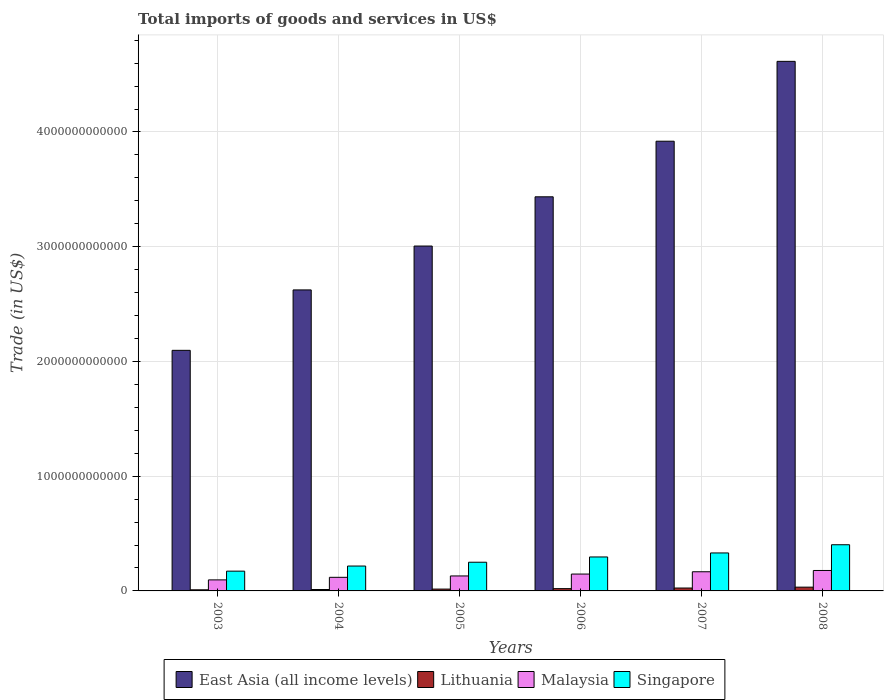How many groups of bars are there?
Make the answer very short. 6. Are the number of bars on each tick of the X-axis equal?
Provide a short and direct response. Yes. How many bars are there on the 5th tick from the left?
Offer a very short reply. 4. What is the total imports of goods and services in Lithuania in 2006?
Offer a very short reply. 1.99e+1. Across all years, what is the maximum total imports of goods and services in Lithuania?
Your response must be concise. 3.29e+1. Across all years, what is the minimum total imports of goods and services in Malaysia?
Ensure brevity in your answer.  9.62e+1. In which year was the total imports of goods and services in Malaysia minimum?
Ensure brevity in your answer.  2003. What is the total total imports of goods and services in Lithuania in the graph?
Ensure brevity in your answer.  1.16e+11. What is the difference between the total imports of goods and services in Singapore in 2003 and that in 2006?
Ensure brevity in your answer.  -1.24e+11. What is the difference between the total imports of goods and services in Singapore in 2007 and the total imports of goods and services in Malaysia in 2006?
Your answer should be very brief. 1.84e+11. What is the average total imports of goods and services in East Asia (all income levels) per year?
Your response must be concise. 3.28e+12. In the year 2005, what is the difference between the total imports of goods and services in Malaysia and total imports of goods and services in East Asia (all income levels)?
Offer a terse response. -2.88e+12. In how many years, is the total imports of goods and services in Lithuania greater than 2800000000000 US$?
Your response must be concise. 0. What is the ratio of the total imports of goods and services in Singapore in 2005 to that in 2008?
Keep it short and to the point. 0.62. Is the total imports of goods and services in East Asia (all income levels) in 2004 less than that in 2007?
Keep it short and to the point. Yes. What is the difference between the highest and the second highest total imports of goods and services in Singapore?
Provide a short and direct response. 7.15e+1. What is the difference between the highest and the lowest total imports of goods and services in Lithuania?
Keep it short and to the point. 2.31e+1. In how many years, is the total imports of goods and services in Lithuania greater than the average total imports of goods and services in Lithuania taken over all years?
Your answer should be very brief. 3. Is it the case that in every year, the sum of the total imports of goods and services in East Asia (all income levels) and total imports of goods and services in Singapore is greater than the sum of total imports of goods and services in Lithuania and total imports of goods and services in Malaysia?
Offer a terse response. No. What does the 1st bar from the left in 2004 represents?
Your answer should be very brief. East Asia (all income levels). What does the 1st bar from the right in 2006 represents?
Provide a succinct answer. Singapore. How many bars are there?
Ensure brevity in your answer.  24. How many years are there in the graph?
Make the answer very short. 6. What is the difference between two consecutive major ticks on the Y-axis?
Give a very brief answer. 1.00e+12. Does the graph contain grids?
Provide a succinct answer. Yes. How many legend labels are there?
Provide a succinct answer. 4. What is the title of the graph?
Your response must be concise. Total imports of goods and services in US$. Does "Estonia" appear as one of the legend labels in the graph?
Your answer should be very brief. No. What is the label or title of the Y-axis?
Offer a very short reply. Trade (in US$). What is the Trade (in US$) of East Asia (all income levels) in 2003?
Your answer should be very brief. 2.10e+12. What is the Trade (in US$) in Lithuania in 2003?
Your answer should be very brief. 9.77e+09. What is the Trade (in US$) of Malaysia in 2003?
Provide a short and direct response. 9.62e+1. What is the Trade (in US$) of Singapore in 2003?
Ensure brevity in your answer.  1.72e+11. What is the Trade (in US$) of East Asia (all income levels) in 2004?
Keep it short and to the point. 2.62e+12. What is the Trade (in US$) of Lithuania in 2004?
Your answer should be very brief. 1.23e+1. What is the Trade (in US$) in Malaysia in 2004?
Your answer should be very brief. 1.19e+11. What is the Trade (in US$) in Singapore in 2004?
Offer a very short reply. 2.17e+11. What is the Trade (in US$) in East Asia (all income levels) in 2005?
Make the answer very short. 3.01e+12. What is the Trade (in US$) of Lithuania in 2005?
Ensure brevity in your answer.  1.60e+1. What is the Trade (in US$) in Malaysia in 2005?
Your answer should be compact. 1.31e+11. What is the Trade (in US$) of Singapore in 2005?
Your response must be concise. 2.50e+11. What is the Trade (in US$) of East Asia (all income levels) in 2006?
Provide a short and direct response. 3.43e+12. What is the Trade (in US$) in Lithuania in 2006?
Offer a very short reply. 1.99e+1. What is the Trade (in US$) of Malaysia in 2006?
Your response must be concise. 1.47e+11. What is the Trade (in US$) in Singapore in 2006?
Keep it short and to the point. 2.96e+11. What is the Trade (in US$) in East Asia (all income levels) in 2007?
Provide a succinct answer. 3.92e+12. What is the Trade (in US$) in Lithuania in 2007?
Keep it short and to the point. 2.52e+1. What is the Trade (in US$) of Malaysia in 2007?
Offer a terse response. 1.67e+11. What is the Trade (in US$) in Singapore in 2007?
Offer a very short reply. 3.31e+11. What is the Trade (in US$) in East Asia (all income levels) in 2008?
Ensure brevity in your answer.  4.62e+12. What is the Trade (in US$) of Lithuania in 2008?
Provide a succinct answer. 3.29e+1. What is the Trade (in US$) of Malaysia in 2008?
Offer a terse response. 1.78e+11. What is the Trade (in US$) of Singapore in 2008?
Your answer should be very brief. 4.02e+11. Across all years, what is the maximum Trade (in US$) of East Asia (all income levels)?
Make the answer very short. 4.62e+12. Across all years, what is the maximum Trade (in US$) of Lithuania?
Offer a terse response. 3.29e+1. Across all years, what is the maximum Trade (in US$) in Malaysia?
Provide a succinct answer. 1.78e+11. Across all years, what is the maximum Trade (in US$) in Singapore?
Your response must be concise. 4.02e+11. Across all years, what is the minimum Trade (in US$) of East Asia (all income levels)?
Give a very brief answer. 2.10e+12. Across all years, what is the minimum Trade (in US$) of Lithuania?
Offer a terse response. 9.77e+09. Across all years, what is the minimum Trade (in US$) in Malaysia?
Your answer should be very brief. 9.62e+1. Across all years, what is the minimum Trade (in US$) in Singapore?
Offer a terse response. 1.72e+11. What is the total Trade (in US$) of East Asia (all income levels) in the graph?
Give a very brief answer. 1.97e+13. What is the total Trade (in US$) of Lithuania in the graph?
Ensure brevity in your answer.  1.16e+11. What is the total Trade (in US$) in Malaysia in the graph?
Offer a very short reply. 8.37e+11. What is the total Trade (in US$) of Singapore in the graph?
Offer a terse response. 1.67e+12. What is the difference between the Trade (in US$) of East Asia (all income levels) in 2003 and that in 2004?
Make the answer very short. -5.27e+11. What is the difference between the Trade (in US$) in Lithuania in 2003 and that in 2004?
Ensure brevity in your answer.  -2.56e+09. What is the difference between the Trade (in US$) in Malaysia in 2003 and that in 2004?
Provide a succinct answer. -2.24e+1. What is the difference between the Trade (in US$) in Singapore in 2003 and that in 2004?
Provide a succinct answer. -4.46e+1. What is the difference between the Trade (in US$) of East Asia (all income levels) in 2003 and that in 2005?
Your answer should be compact. -9.09e+11. What is the difference between the Trade (in US$) of Lithuania in 2003 and that in 2005?
Offer a terse response. -6.19e+09. What is the difference between the Trade (in US$) in Malaysia in 2003 and that in 2005?
Offer a terse response. -3.44e+1. What is the difference between the Trade (in US$) of Singapore in 2003 and that in 2005?
Offer a very short reply. -7.78e+1. What is the difference between the Trade (in US$) of East Asia (all income levels) in 2003 and that in 2006?
Your response must be concise. -1.34e+12. What is the difference between the Trade (in US$) of Lithuania in 2003 and that in 2006?
Offer a very short reply. -1.01e+1. What is the difference between the Trade (in US$) in Malaysia in 2003 and that in 2006?
Provide a succinct answer. -5.09e+1. What is the difference between the Trade (in US$) in Singapore in 2003 and that in 2006?
Offer a very short reply. -1.24e+11. What is the difference between the Trade (in US$) in East Asia (all income levels) in 2003 and that in 2007?
Ensure brevity in your answer.  -1.82e+12. What is the difference between the Trade (in US$) in Lithuania in 2003 and that in 2007?
Make the answer very short. -1.55e+1. What is the difference between the Trade (in US$) of Malaysia in 2003 and that in 2007?
Your answer should be compact. -7.09e+1. What is the difference between the Trade (in US$) in Singapore in 2003 and that in 2007?
Offer a terse response. -1.59e+11. What is the difference between the Trade (in US$) of East Asia (all income levels) in 2003 and that in 2008?
Keep it short and to the point. -2.52e+12. What is the difference between the Trade (in US$) of Lithuania in 2003 and that in 2008?
Provide a short and direct response. -2.31e+1. What is the difference between the Trade (in US$) of Malaysia in 2003 and that in 2008?
Provide a succinct answer. -8.20e+1. What is the difference between the Trade (in US$) in Singapore in 2003 and that in 2008?
Give a very brief answer. -2.30e+11. What is the difference between the Trade (in US$) of East Asia (all income levels) in 2004 and that in 2005?
Provide a short and direct response. -3.82e+11. What is the difference between the Trade (in US$) of Lithuania in 2004 and that in 2005?
Ensure brevity in your answer.  -3.64e+09. What is the difference between the Trade (in US$) in Malaysia in 2004 and that in 2005?
Make the answer very short. -1.20e+1. What is the difference between the Trade (in US$) of Singapore in 2004 and that in 2005?
Provide a succinct answer. -3.32e+1. What is the difference between the Trade (in US$) in East Asia (all income levels) in 2004 and that in 2006?
Provide a short and direct response. -8.12e+11. What is the difference between the Trade (in US$) in Lithuania in 2004 and that in 2006?
Keep it short and to the point. -7.59e+09. What is the difference between the Trade (in US$) in Malaysia in 2004 and that in 2006?
Your answer should be very brief. -2.85e+1. What is the difference between the Trade (in US$) in Singapore in 2004 and that in 2006?
Offer a terse response. -7.91e+1. What is the difference between the Trade (in US$) in East Asia (all income levels) in 2004 and that in 2007?
Make the answer very short. -1.30e+12. What is the difference between the Trade (in US$) of Lithuania in 2004 and that in 2007?
Ensure brevity in your answer.  -1.29e+1. What is the difference between the Trade (in US$) of Malaysia in 2004 and that in 2007?
Give a very brief answer. -4.85e+1. What is the difference between the Trade (in US$) in Singapore in 2004 and that in 2007?
Provide a succinct answer. -1.14e+11. What is the difference between the Trade (in US$) of East Asia (all income levels) in 2004 and that in 2008?
Ensure brevity in your answer.  -1.99e+12. What is the difference between the Trade (in US$) of Lithuania in 2004 and that in 2008?
Offer a terse response. -2.06e+1. What is the difference between the Trade (in US$) of Malaysia in 2004 and that in 2008?
Make the answer very short. -5.96e+1. What is the difference between the Trade (in US$) in Singapore in 2004 and that in 2008?
Your answer should be very brief. -1.86e+11. What is the difference between the Trade (in US$) of East Asia (all income levels) in 2005 and that in 2006?
Your answer should be very brief. -4.29e+11. What is the difference between the Trade (in US$) in Lithuania in 2005 and that in 2006?
Give a very brief answer. -3.95e+09. What is the difference between the Trade (in US$) of Malaysia in 2005 and that in 2006?
Give a very brief answer. -1.65e+1. What is the difference between the Trade (in US$) of Singapore in 2005 and that in 2006?
Your response must be concise. -4.59e+1. What is the difference between the Trade (in US$) in East Asia (all income levels) in 2005 and that in 2007?
Your answer should be compact. -9.14e+11. What is the difference between the Trade (in US$) of Lithuania in 2005 and that in 2007?
Offer a terse response. -9.27e+09. What is the difference between the Trade (in US$) of Malaysia in 2005 and that in 2007?
Give a very brief answer. -3.65e+1. What is the difference between the Trade (in US$) in Singapore in 2005 and that in 2007?
Give a very brief answer. -8.10e+1. What is the difference between the Trade (in US$) in East Asia (all income levels) in 2005 and that in 2008?
Offer a very short reply. -1.61e+12. What is the difference between the Trade (in US$) in Lithuania in 2005 and that in 2008?
Make the answer very short. -1.69e+1. What is the difference between the Trade (in US$) of Malaysia in 2005 and that in 2008?
Your answer should be very brief. -4.76e+1. What is the difference between the Trade (in US$) of Singapore in 2005 and that in 2008?
Your answer should be very brief. -1.52e+11. What is the difference between the Trade (in US$) in East Asia (all income levels) in 2006 and that in 2007?
Provide a succinct answer. -4.84e+11. What is the difference between the Trade (in US$) in Lithuania in 2006 and that in 2007?
Offer a terse response. -5.32e+09. What is the difference between the Trade (in US$) in Malaysia in 2006 and that in 2007?
Provide a succinct answer. -2.00e+1. What is the difference between the Trade (in US$) of Singapore in 2006 and that in 2007?
Provide a short and direct response. -3.50e+1. What is the difference between the Trade (in US$) in East Asia (all income levels) in 2006 and that in 2008?
Provide a succinct answer. -1.18e+12. What is the difference between the Trade (in US$) in Lithuania in 2006 and that in 2008?
Give a very brief answer. -1.30e+1. What is the difference between the Trade (in US$) of Malaysia in 2006 and that in 2008?
Your answer should be compact. -3.11e+1. What is the difference between the Trade (in US$) of Singapore in 2006 and that in 2008?
Provide a succinct answer. -1.07e+11. What is the difference between the Trade (in US$) of East Asia (all income levels) in 2007 and that in 2008?
Ensure brevity in your answer.  -6.96e+11. What is the difference between the Trade (in US$) of Lithuania in 2007 and that in 2008?
Give a very brief answer. -7.65e+09. What is the difference between the Trade (in US$) of Malaysia in 2007 and that in 2008?
Provide a succinct answer. -1.11e+1. What is the difference between the Trade (in US$) in Singapore in 2007 and that in 2008?
Give a very brief answer. -7.15e+1. What is the difference between the Trade (in US$) in East Asia (all income levels) in 2003 and the Trade (in US$) in Lithuania in 2004?
Provide a succinct answer. 2.08e+12. What is the difference between the Trade (in US$) in East Asia (all income levels) in 2003 and the Trade (in US$) in Malaysia in 2004?
Your response must be concise. 1.98e+12. What is the difference between the Trade (in US$) in East Asia (all income levels) in 2003 and the Trade (in US$) in Singapore in 2004?
Offer a terse response. 1.88e+12. What is the difference between the Trade (in US$) of Lithuania in 2003 and the Trade (in US$) of Malaysia in 2004?
Provide a short and direct response. -1.09e+11. What is the difference between the Trade (in US$) in Lithuania in 2003 and the Trade (in US$) in Singapore in 2004?
Keep it short and to the point. -2.07e+11. What is the difference between the Trade (in US$) in Malaysia in 2003 and the Trade (in US$) in Singapore in 2004?
Offer a very short reply. -1.21e+11. What is the difference between the Trade (in US$) in East Asia (all income levels) in 2003 and the Trade (in US$) in Lithuania in 2005?
Your answer should be very brief. 2.08e+12. What is the difference between the Trade (in US$) of East Asia (all income levels) in 2003 and the Trade (in US$) of Malaysia in 2005?
Your response must be concise. 1.97e+12. What is the difference between the Trade (in US$) in East Asia (all income levels) in 2003 and the Trade (in US$) in Singapore in 2005?
Offer a very short reply. 1.85e+12. What is the difference between the Trade (in US$) in Lithuania in 2003 and the Trade (in US$) in Malaysia in 2005?
Keep it short and to the point. -1.21e+11. What is the difference between the Trade (in US$) of Lithuania in 2003 and the Trade (in US$) of Singapore in 2005?
Provide a short and direct response. -2.40e+11. What is the difference between the Trade (in US$) in Malaysia in 2003 and the Trade (in US$) in Singapore in 2005?
Provide a short and direct response. -1.54e+11. What is the difference between the Trade (in US$) of East Asia (all income levels) in 2003 and the Trade (in US$) of Lithuania in 2006?
Your answer should be compact. 2.08e+12. What is the difference between the Trade (in US$) in East Asia (all income levels) in 2003 and the Trade (in US$) in Malaysia in 2006?
Give a very brief answer. 1.95e+12. What is the difference between the Trade (in US$) in East Asia (all income levels) in 2003 and the Trade (in US$) in Singapore in 2006?
Offer a terse response. 1.80e+12. What is the difference between the Trade (in US$) of Lithuania in 2003 and the Trade (in US$) of Malaysia in 2006?
Offer a terse response. -1.37e+11. What is the difference between the Trade (in US$) in Lithuania in 2003 and the Trade (in US$) in Singapore in 2006?
Your answer should be very brief. -2.86e+11. What is the difference between the Trade (in US$) in Malaysia in 2003 and the Trade (in US$) in Singapore in 2006?
Offer a terse response. -2.00e+11. What is the difference between the Trade (in US$) of East Asia (all income levels) in 2003 and the Trade (in US$) of Lithuania in 2007?
Provide a succinct answer. 2.07e+12. What is the difference between the Trade (in US$) in East Asia (all income levels) in 2003 and the Trade (in US$) in Malaysia in 2007?
Give a very brief answer. 1.93e+12. What is the difference between the Trade (in US$) of East Asia (all income levels) in 2003 and the Trade (in US$) of Singapore in 2007?
Your answer should be compact. 1.77e+12. What is the difference between the Trade (in US$) in Lithuania in 2003 and the Trade (in US$) in Malaysia in 2007?
Your response must be concise. -1.57e+11. What is the difference between the Trade (in US$) of Lithuania in 2003 and the Trade (in US$) of Singapore in 2007?
Make the answer very short. -3.21e+11. What is the difference between the Trade (in US$) in Malaysia in 2003 and the Trade (in US$) in Singapore in 2007?
Keep it short and to the point. -2.35e+11. What is the difference between the Trade (in US$) in East Asia (all income levels) in 2003 and the Trade (in US$) in Lithuania in 2008?
Give a very brief answer. 2.06e+12. What is the difference between the Trade (in US$) of East Asia (all income levels) in 2003 and the Trade (in US$) of Malaysia in 2008?
Provide a short and direct response. 1.92e+12. What is the difference between the Trade (in US$) in East Asia (all income levels) in 2003 and the Trade (in US$) in Singapore in 2008?
Your answer should be very brief. 1.69e+12. What is the difference between the Trade (in US$) in Lithuania in 2003 and the Trade (in US$) in Malaysia in 2008?
Give a very brief answer. -1.68e+11. What is the difference between the Trade (in US$) in Lithuania in 2003 and the Trade (in US$) in Singapore in 2008?
Make the answer very short. -3.93e+11. What is the difference between the Trade (in US$) in Malaysia in 2003 and the Trade (in US$) in Singapore in 2008?
Give a very brief answer. -3.06e+11. What is the difference between the Trade (in US$) of East Asia (all income levels) in 2004 and the Trade (in US$) of Lithuania in 2005?
Provide a short and direct response. 2.61e+12. What is the difference between the Trade (in US$) in East Asia (all income levels) in 2004 and the Trade (in US$) in Malaysia in 2005?
Give a very brief answer. 2.49e+12. What is the difference between the Trade (in US$) of East Asia (all income levels) in 2004 and the Trade (in US$) of Singapore in 2005?
Offer a very short reply. 2.37e+12. What is the difference between the Trade (in US$) of Lithuania in 2004 and the Trade (in US$) of Malaysia in 2005?
Offer a very short reply. -1.18e+11. What is the difference between the Trade (in US$) in Lithuania in 2004 and the Trade (in US$) in Singapore in 2005?
Offer a very short reply. -2.38e+11. What is the difference between the Trade (in US$) in Malaysia in 2004 and the Trade (in US$) in Singapore in 2005?
Keep it short and to the point. -1.32e+11. What is the difference between the Trade (in US$) in East Asia (all income levels) in 2004 and the Trade (in US$) in Lithuania in 2006?
Provide a succinct answer. 2.60e+12. What is the difference between the Trade (in US$) of East Asia (all income levels) in 2004 and the Trade (in US$) of Malaysia in 2006?
Give a very brief answer. 2.48e+12. What is the difference between the Trade (in US$) of East Asia (all income levels) in 2004 and the Trade (in US$) of Singapore in 2006?
Your answer should be very brief. 2.33e+12. What is the difference between the Trade (in US$) in Lithuania in 2004 and the Trade (in US$) in Malaysia in 2006?
Your answer should be very brief. -1.35e+11. What is the difference between the Trade (in US$) in Lithuania in 2004 and the Trade (in US$) in Singapore in 2006?
Provide a succinct answer. -2.84e+11. What is the difference between the Trade (in US$) of Malaysia in 2004 and the Trade (in US$) of Singapore in 2006?
Offer a terse response. -1.77e+11. What is the difference between the Trade (in US$) of East Asia (all income levels) in 2004 and the Trade (in US$) of Lithuania in 2007?
Your answer should be compact. 2.60e+12. What is the difference between the Trade (in US$) of East Asia (all income levels) in 2004 and the Trade (in US$) of Malaysia in 2007?
Provide a short and direct response. 2.46e+12. What is the difference between the Trade (in US$) in East Asia (all income levels) in 2004 and the Trade (in US$) in Singapore in 2007?
Your answer should be very brief. 2.29e+12. What is the difference between the Trade (in US$) in Lithuania in 2004 and the Trade (in US$) in Malaysia in 2007?
Offer a terse response. -1.55e+11. What is the difference between the Trade (in US$) of Lithuania in 2004 and the Trade (in US$) of Singapore in 2007?
Offer a terse response. -3.19e+11. What is the difference between the Trade (in US$) of Malaysia in 2004 and the Trade (in US$) of Singapore in 2007?
Your answer should be very brief. -2.13e+11. What is the difference between the Trade (in US$) in East Asia (all income levels) in 2004 and the Trade (in US$) in Lithuania in 2008?
Offer a terse response. 2.59e+12. What is the difference between the Trade (in US$) of East Asia (all income levels) in 2004 and the Trade (in US$) of Malaysia in 2008?
Keep it short and to the point. 2.45e+12. What is the difference between the Trade (in US$) of East Asia (all income levels) in 2004 and the Trade (in US$) of Singapore in 2008?
Provide a short and direct response. 2.22e+12. What is the difference between the Trade (in US$) of Lithuania in 2004 and the Trade (in US$) of Malaysia in 2008?
Offer a terse response. -1.66e+11. What is the difference between the Trade (in US$) in Lithuania in 2004 and the Trade (in US$) in Singapore in 2008?
Your answer should be compact. -3.90e+11. What is the difference between the Trade (in US$) of Malaysia in 2004 and the Trade (in US$) of Singapore in 2008?
Your answer should be compact. -2.84e+11. What is the difference between the Trade (in US$) of East Asia (all income levels) in 2005 and the Trade (in US$) of Lithuania in 2006?
Keep it short and to the point. 2.99e+12. What is the difference between the Trade (in US$) of East Asia (all income levels) in 2005 and the Trade (in US$) of Malaysia in 2006?
Make the answer very short. 2.86e+12. What is the difference between the Trade (in US$) of East Asia (all income levels) in 2005 and the Trade (in US$) of Singapore in 2006?
Offer a terse response. 2.71e+12. What is the difference between the Trade (in US$) of Lithuania in 2005 and the Trade (in US$) of Malaysia in 2006?
Provide a succinct answer. -1.31e+11. What is the difference between the Trade (in US$) of Lithuania in 2005 and the Trade (in US$) of Singapore in 2006?
Provide a succinct answer. -2.80e+11. What is the difference between the Trade (in US$) in Malaysia in 2005 and the Trade (in US$) in Singapore in 2006?
Your answer should be compact. -1.65e+11. What is the difference between the Trade (in US$) of East Asia (all income levels) in 2005 and the Trade (in US$) of Lithuania in 2007?
Provide a succinct answer. 2.98e+12. What is the difference between the Trade (in US$) in East Asia (all income levels) in 2005 and the Trade (in US$) in Malaysia in 2007?
Offer a very short reply. 2.84e+12. What is the difference between the Trade (in US$) of East Asia (all income levels) in 2005 and the Trade (in US$) of Singapore in 2007?
Provide a short and direct response. 2.67e+12. What is the difference between the Trade (in US$) of Lithuania in 2005 and the Trade (in US$) of Malaysia in 2007?
Your answer should be very brief. -1.51e+11. What is the difference between the Trade (in US$) in Lithuania in 2005 and the Trade (in US$) in Singapore in 2007?
Provide a short and direct response. -3.15e+11. What is the difference between the Trade (in US$) of Malaysia in 2005 and the Trade (in US$) of Singapore in 2007?
Offer a very short reply. -2.00e+11. What is the difference between the Trade (in US$) of East Asia (all income levels) in 2005 and the Trade (in US$) of Lithuania in 2008?
Your answer should be compact. 2.97e+12. What is the difference between the Trade (in US$) in East Asia (all income levels) in 2005 and the Trade (in US$) in Malaysia in 2008?
Provide a succinct answer. 2.83e+12. What is the difference between the Trade (in US$) of East Asia (all income levels) in 2005 and the Trade (in US$) of Singapore in 2008?
Provide a succinct answer. 2.60e+12. What is the difference between the Trade (in US$) of Lithuania in 2005 and the Trade (in US$) of Malaysia in 2008?
Keep it short and to the point. -1.62e+11. What is the difference between the Trade (in US$) in Lithuania in 2005 and the Trade (in US$) in Singapore in 2008?
Your answer should be compact. -3.87e+11. What is the difference between the Trade (in US$) of Malaysia in 2005 and the Trade (in US$) of Singapore in 2008?
Offer a very short reply. -2.72e+11. What is the difference between the Trade (in US$) of East Asia (all income levels) in 2006 and the Trade (in US$) of Lithuania in 2007?
Your answer should be compact. 3.41e+12. What is the difference between the Trade (in US$) in East Asia (all income levels) in 2006 and the Trade (in US$) in Malaysia in 2007?
Ensure brevity in your answer.  3.27e+12. What is the difference between the Trade (in US$) of East Asia (all income levels) in 2006 and the Trade (in US$) of Singapore in 2007?
Keep it short and to the point. 3.10e+12. What is the difference between the Trade (in US$) in Lithuania in 2006 and the Trade (in US$) in Malaysia in 2007?
Offer a terse response. -1.47e+11. What is the difference between the Trade (in US$) in Lithuania in 2006 and the Trade (in US$) in Singapore in 2007?
Your answer should be very brief. -3.11e+11. What is the difference between the Trade (in US$) of Malaysia in 2006 and the Trade (in US$) of Singapore in 2007?
Your answer should be compact. -1.84e+11. What is the difference between the Trade (in US$) of East Asia (all income levels) in 2006 and the Trade (in US$) of Lithuania in 2008?
Make the answer very short. 3.40e+12. What is the difference between the Trade (in US$) in East Asia (all income levels) in 2006 and the Trade (in US$) in Malaysia in 2008?
Ensure brevity in your answer.  3.26e+12. What is the difference between the Trade (in US$) of East Asia (all income levels) in 2006 and the Trade (in US$) of Singapore in 2008?
Your answer should be very brief. 3.03e+12. What is the difference between the Trade (in US$) in Lithuania in 2006 and the Trade (in US$) in Malaysia in 2008?
Your answer should be very brief. -1.58e+11. What is the difference between the Trade (in US$) in Lithuania in 2006 and the Trade (in US$) in Singapore in 2008?
Provide a succinct answer. -3.83e+11. What is the difference between the Trade (in US$) of Malaysia in 2006 and the Trade (in US$) of Singapore in 2008?
Make the answer very short. -2.55e+11. What is the difference between the Trade (in US$) in East Asia (all income levels) in 2007 and the Trade (in US$) in Lithuania in 2008?
Provide a succinct answer. 3.89e+12. What is the difference between the Trade (in US$) in East Asia (all income levels) in 2007 and the Trade (in US$) in Malaysia in 2008?
Make the answer very short. 3.74e+12. What is the difference between the Trade (in US$) in East Asia (all income levels) in 2007 and the Trade (in US$) in Singapore in 2008?
Keep it short and to the point. 3.52e+12. What is the difference between the Trade (in US$) in Lithuania in 2007 and the Trade (in US$) in Malaysia in 2008?
Make the answer very short. -1.53e+11. What is the difference between the Trade (in US$) in Lithuania in 2007 and the Trade (in US$) in Singapore in 2008?
Keep it short and to the point. -3.77e+11. What is the difference between the Trade (in US$) in Malaysia in 2007 and the Trade (in US$) in Singapore in 2008?
Make the answer very short. -2.35e+11. What is the average Trade (in US$) in East Asia (all income levels) per year?
Your response must be concise. 3.28e+12. What is the average Trade (in US$) of Lithuania per year?
Your answer should be compact. 1.93e+1. What is the average Trade (in US$) of Malaysia per year?
Provide a short and direct response. 1.40e+11. What is the average Trade (in US$) in Singapore per year?
Your answer should be very brief. 2.78e+11. In the year 2003, what is the difference between the Trade (in US$) in East Asia (all income levels) and Trade (in US$) in Lithuania?
Offer a terse response. 2.09e+12. In the year 2003, what is the difference between the Trade (in US$) of East Asia (all income levels) and Trade (in US$) of Malaysia?
Your response must be concise. 2.00e+12. In the year 2003, what is the difference between the Trade (in US$) in East Asia (all income levels) and Trade (in US$) in Singapore?
Ensure brevity in your answer.  1.92e+12. In the year 2003, what is the difference between the Trade (in US$) in Lithuania and Trade (in US$) in Malaysia?
Your answer should be very brief. -8.64e+1. In the year 2003, what is the difference between the Trade (in US$) in Lithuania and Trade (in US$) in Singapore?
Make the answer very short. -1.63e+11. In the year 2003, what is the difference between the Trade (in US$) of Malaysia and Trade (in US$) of Singapore?
Offer a terse response. -7.61e+1. In the year 2004, what is the difference between the Trade (in US$) of East Asia (all income levels) and Trade (in US$) of Lithuania?
Your answer should be compact. 2.61e+12. In the year 2004, what is the difference between the Trade (in US$) in East Asia (all income levels) and Trade (in US$) in Malaysia?
Provide a succinct answer. 2.50e+12. In the year 2004, what is the difference between the Trade (in US$) of East Asia (all income levels) and Trade (in US$) of Singapore?
Give a very brief answer. 2.41e+12. In the year 2004, what is the difference between the Trade (in US$) in Lithuania and Trade (in US$) in Malaysia?
Ensure brevity in your answer.  -1.06e+11. In the year 2004, what is the difference between the Trade (in US$) of Lithuania and Trade (in US$) of Singapore?
Offer a very short reply. -2.05e+11. In the year 2004, what is the difference between the Trade (in US$) in Malaysia and Trade (in US$) in Singapore?
Keep it short and to the point. -9.84e+1. In the year 2005, what is the difference between the Trade (in US$) in East Asia (all income levels) and Trade (in US$) in Lithuania?
Your response must be concise. 2.99e+12. In the year 2005, what is the difference between the Trade (in US$) in East Asia (all income levels) and Trade (in US$) in Malaysia?
Ensure brevity in your answer.  2.88e+12. In the year 2005, what is the difference between the Trade (in US$) in East Asia (all income levels) and Trade (in US$) in Singapore?
Your answer should be very brief. 2.76e+12. In the year 2005, what is the difference between the Trade (in US$) in Lithuania and Trade (in US$) in Malaysia?
Provide a short and direct response. -1.15e+11. In the year 2005, what is the difference between the Trade (in US$) in Lithuania and Trade (in US$) in Singapore?
Offer a very short reply. -2.34e+11. In the year 2005, what is the difference between the Trade (in US$) in Malaysia and Trade (in US$) in Singapore?
Keep it short and to the point. -1.20e+11. In the year 2006, what is the difference between the Trade (in US$) in East Asia (all income levels) and Trade (in US$) in Lithuania?
Provide a short and direct response. 3.42e+12. In the year 2006, what is the difference between the Trade (in US$) in East Asia (all income levels) and Trade (in US$) in Malaysia?
Ensure brevity in your answer.  3.29e+12. In the year 2006, what is the difference between the Trade (in US$) of East Asia (all income levels) and Trade (in US$) of Singapore?
Offer a terse response. 3.14e+12. In the year 2006, what is the difference between the Trade (in US$) of Lithuania and Trade (in US$) of Malaysia?
Provide a succinct answer. -1.27e+11. In the year 2006, what is the difference between the Trade (in US$) in Lithuania and Trade (in US$) in Singapore?
Provide a succinct answer. -2.76e+11. In the year 2006, what is the difference between the Trade (in US$) in Malaysia and Trade (in US$) in Singapore?
Make the answer very short. -1.49e+11. In the year 2007, what is the difference between the Trade (in US$) in East Asia (all income levels) and Trade (in US$) in Lithuania?
Make the answer very short. 3.89e+12. In the year 2007, what is the difference between the Trade (in US$) of East Asia (all income levels) and Trade (in US$) of Malaysia?
Provide a short and direct response. 3.75e+12. In the year 2007, what is the difference between the Trade (in US$) of East Asia (all income levels) and Trade (in US$) of Singapore?
Your response must be concise. 3.59e+12. In the year 2007, what is the difference between the Trade (in US$) in Lithuania and Trade (in US$) in Malaysia?
Provide a short and direct response. -1.42e+11. In the year 2007, what is the difference between the Trade (in US$) in Lithuania and Trade (in US$) in Singapore?
Give a very brief answer. -3.06e+11. In the year 2007, what is the difference between the Trade (in US$) in Malaysia and Trade (in US$) in Singapore?
Provide a succinct answer. -1.64e+11. In the year 2008, what is the difference between the Trade (in US$) of East Asia (all income levels) and Trade (in US$) of Lithuania?
Make the answer very short. 4.58e+12. In the year 2008, what is the difference between the Trade (in US$) of East Asia (all income levels) and Trade (in US$) of Malaysia?
Your response must be concise. 4.44e+12. In the year 2008, what is the difference between the Trade (in US$) of East Asia (all income levels) and Trade (in US$) of Singapore?
Your response must be concise. 4.21e+12. In the year 2008, what is the difference between the Trade (in US$) of Lithuania and Trade (in US$) of Malaysia?
Make the answer very short. -1.45e+11. In the year 2008, what is the difference between the Trade (in US$) of Lithuania and Trade (in US$) of Singapore?
Make the answer very short. -3.70e+11. In the year 2008, what is the difference between the Trade (in US$) in Malaysia and Trade (in US$) in Singapore?
Give a very brief answer. -2.24e+11. What is the ratio of the Trade (in US$) in East Asia (all income levels) in 2003 to that in 2004?
Offer a terse response. 0.8. What is the ratio of the Trade (in US$) in Lithuania in 2003 to that in 2004?
Ensure brevity in your answer.  0.79. What is the ratio of the Trade (in US$) of Malaysia in 2003 to that in 2004?
Ensure brevity in your answer.  0.81. What is the ratio of the Trade (in US$) of Singapore in 2003 to that in 2004?
Provide a short and direct response. 0.79. What is the ratio of the Trade (in US$) of East Asia (all income levels) in 2003 to that in 2005?
Your response must be concise. 0.7. What is the ratio of the Trade (in US$) in Lithuania in 2003 to that in 2005?
Offer a terse response. 0.61. What is the ratio of the Trade (in US$) in Malaysia in 2003 to that in 2005?
Provide a succinct answer. 0.74. What is the ratio of the Trade (in US$) of Singapore in 2003 to that in 2005?
Make the answer very short. 0.69. What is the ratio of the Trade (in US$) of East Asia (all income levels) in 2003 to that in 2006?
Offer a very short reply. 0.61. What is the ratio of the Trade (in US$) of Lithuania in 2003 to that in 2006?
Your answer should be compact. 0.49. What is the ratio of the Trade (in US$) in Malaysia in 2003 to that in 2006?
Provide a short and direct response. 0.65. What is the ratio of the Trade (in US$) in Singapore in 2003 to that in 2006?
Your answer should be compact. 0.58. What is the ratio of the Trade (in US$) of East Asia (all income levels) in 2003 to that in 2007?
Provide a succinct answer. 0.54. What is the ratio of the Trade (in US$) in Lithuania in 2003 to that in 2007?
Your answer should be compact. 0.39. What is the ratio of the Trade (in US$) of Malaysia in 2003 to that in 2007?
Keep it short and to the point. 0.58. What is the ratio of the Trade (in US$) in Singapore in 2003 to that in 2007?
Ensure brevity in your answer.  0.52. What is the ratio of the Trade (in US$) of East Asia (all income levels) in 2003 to that in 2008?
Your answer should be very brief. 0.45. What is the ratio of the Trade (in US$) in Lithuania in 2003 to that in 2008?
Offer a very short reply. 0.3. What is the ratio of the Trade (in US$) in Malaysia in 2003 to that in 2008?
Keep it short and to the point. 0.54. What is the ratio of the Trade (in US$) of Singapore in 2003 to that in 2008?
Ensure brevity in your answer.  0.43. What is the ratio of the Trade (in US$) of East Asia (all income levels) in 2004 to that in 2005?
Your answer should be very brief. 0.87. What is the ratio of the Trade (in US$) in Lithuania in 2004 to that in 2005?
Keep it short and to the point. 0.77. What is the ratio of the Trade (in US$) in Malaysia in 2004 to that in 2005?
Keep it short and to the point. 0.91. What is the ratio of the Trade (in US$) of Singapore in 2004 to that in 2005?
Your answer should be compact. 0.87. What is the ratio of the Trade (in US$) in East Asia (all income levels) in 2004 to that in 2006?
Offer a terse response. 0.76. What is the ratio of the Trade (in US$) in Lithuania in 2004 to that in 2006?
Make the answer very short. 0.62. What is the ratio of the Trade (in US$) of Malaysia in 2004 to that in 2006?
Your response must be concise. 0.81. What is the ratio of the Trade (in US$) of Singapore in 2004 to that in 2006?
Provide a short and direct response. 0.73. What is the ratio of the Trade (in US$) in East Asia (all income levels) in 2004 to that in 2007?
Make the answer very short. 0.67. What is the ratio of the Trade (in US$) in Lithuania in 2004 to that in 2007?
Provide a short and direct response. 0.49. What is the ratio of the Trade (in US$) of Malaysia in 2004 to that in 2007?
Provide a short and direct response. 0.71. What is the ratio of the Trade (in US$) of Singapore in 2004 to that in 2007?
Your answer should be compact. 0.66. What is the ratio of the Trade (in US$) in East Asia (all income levels) in 2004 to that in 2008?
Keep it short and to the point. 0.57. What is the ratio of the Trade (in US$) of Lithuania in 2004 to that in 2008?
Provide a short and direct response. 0.37. What is the ratio of the Trade (in US$) in Malaysia in 2004 to that in 2008?
Keep it short and to the point. 0.67. What is the ratio of the Trade (in US$) of Singapore in 2004 to that in 2008?
Offer a terse response. 0.54. What is the ratio of the Trade (in US$) in East Asia (all income levels) in 2005 to that in 2006?
Keep it short and to the point. 0.88. What is the ratio of the Trade (in US$) of Lithuania in 2005 to that in 2006?
Give a very brief answer. 0.8. What is the ratio of the Trade (in US$) in Malaysia in 2005 to that in 2006?
Give a very brief answer. 0.89. What is the ratio of the Trade (in US$) of Singapore in 2005 to that in 2006?
Provide a succinct answer. 0.84. What is the ratio of the Trade (in US$) in East Asia (all income levels) in 2005 to that in 2007?
Offer a terse response. 0.77. What is the ratio of the Trade (in US$) in Lithuania in 2005 to that in 2007?
Offer a very short reply. 0.63. What is the ratio of the Trade (in US$) of Malaysia in 2005 to that in 2007?
Provide a short and direct response. 0.78. What is the ratio of the Trade (in US$) in Singapore in 2005 to that in 2007?
Offer a very short reply. 0.76. What is the ratio of the Trade (in US$) in East Asia (all income levels) in 2005 to that in 2008?
Ensure brevity in your answer.  0.65. What is the ratio of the Trade (in US$) of Lithuania in 2005 to that in 2008?
Offer a very short reply. 0.49. What is the ratio of the Trade (in US$) in Malaysia in 2005 to that in 2008?
Offer a very short reply. 0.73. What is the ratio of the Trade (in US$) in Singapore in 2005 to that in 2008?
Keep it short and to the point. 0.62. What is the ratio of the Trade (in US$) in East Asia (all income levels) in 2006 to that in 2007?
Provide a succinct answer. 0.88. What is the ratio of the Trade (in US$) of Lithuania in 2006 to that in 2007?
Your response must be concise. 0.79. What is the ratio of the Trade (in US$) in Malaysia in 2006 to that in 2007?
Your answer should be very brief. 0.88. What is the ratio of the Trade (in US$) in Singapore in 2006 to that in 2007?
Offer a terse response. 0.89. What is the ratio of the Trade (in US$) in East Asia (all income levels) in 2006 to that in 2008?
Your answer should be compact. 0.74. What is the ratio of the Trade (in US$) in Lithuania in 2006 to that in 2008?
Your response must be concise. 0.61. What is the ratio of the Trade (in US$) in Malaysia in 2006 to that in 2008?
Offer a terse response. 0.83. What is the ratio of the Trade (in US$) of Singapore in 2006 to that in 2008?
Your answer should be very brief. 0.74. What is the ratio of the Trade (in US$) of East Asia (all income levels) in 2007 to that in 2008?
Your answer should be very brief. 0.85. What is the ratio of the Trade (in US$) in Lithuania in 2007 to that in 2008?
Offer a very short reply. 0.77. What is the ratio of the Trade (in US$) of Malaysia in 2007 to that in 2008?
Make the answer very short. 0.94. What is the ratio of the Trade (in US$) in Singapore in 2007 to that in 2008?
Your response must be concise. 0.82. What is the difference between the highest and the second highest Trade (in US$) of East Asia (all income levels)?
Give a very brief answer. 6.96e+11. What is the difference between the highest and the second highest Trade (in US$) in Lithuania?
Give a very brief answer. 7.65e+09. What is the difference between the highest and the second highest Trade (in US$) of Malaysia?
Offer a very short reply. 1.11e+1. What is the difference between the highest and the second highest Trade (in US$) of Singapore?
Your answer should be compact. 7.15e+1. What is the difference between the highest and the lowest Trade (in US$) in East Asia (all income levels)?
Offer a terse response. 2.52e+12. What is the difference between the highest and the lowest Trade (in US$) in Lithuania?
Ensure brevity in your answer.  2.31e+1. What is the difference between the highest and the lowest Trade (in US$) of Malaysia?
Ensure brevity in your answer.  8.20e+1. What is the difference between the highest and the lowest Trade (in US$) of Singapore?
Provide a succinct answer. 2.30e+11. 